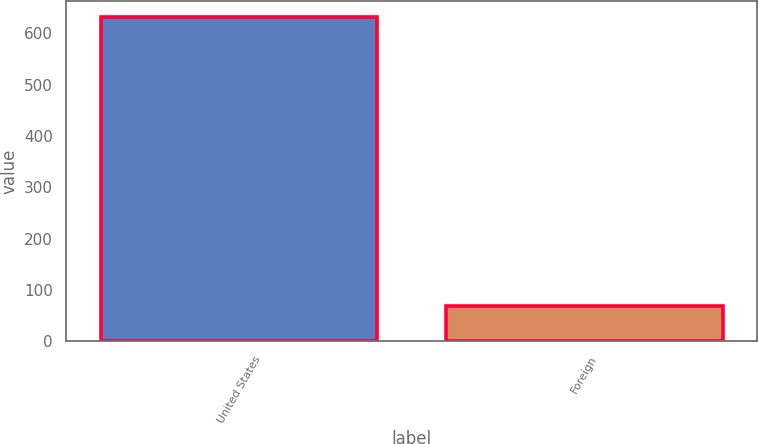Convert chart to OTSL. <chart><loc_0><loc_0><loc_500><loc_500><bar_chart><fcel>United States<fcel>Foreign<nl><fcel>631.9<fcel>69.6<nl></chart> 